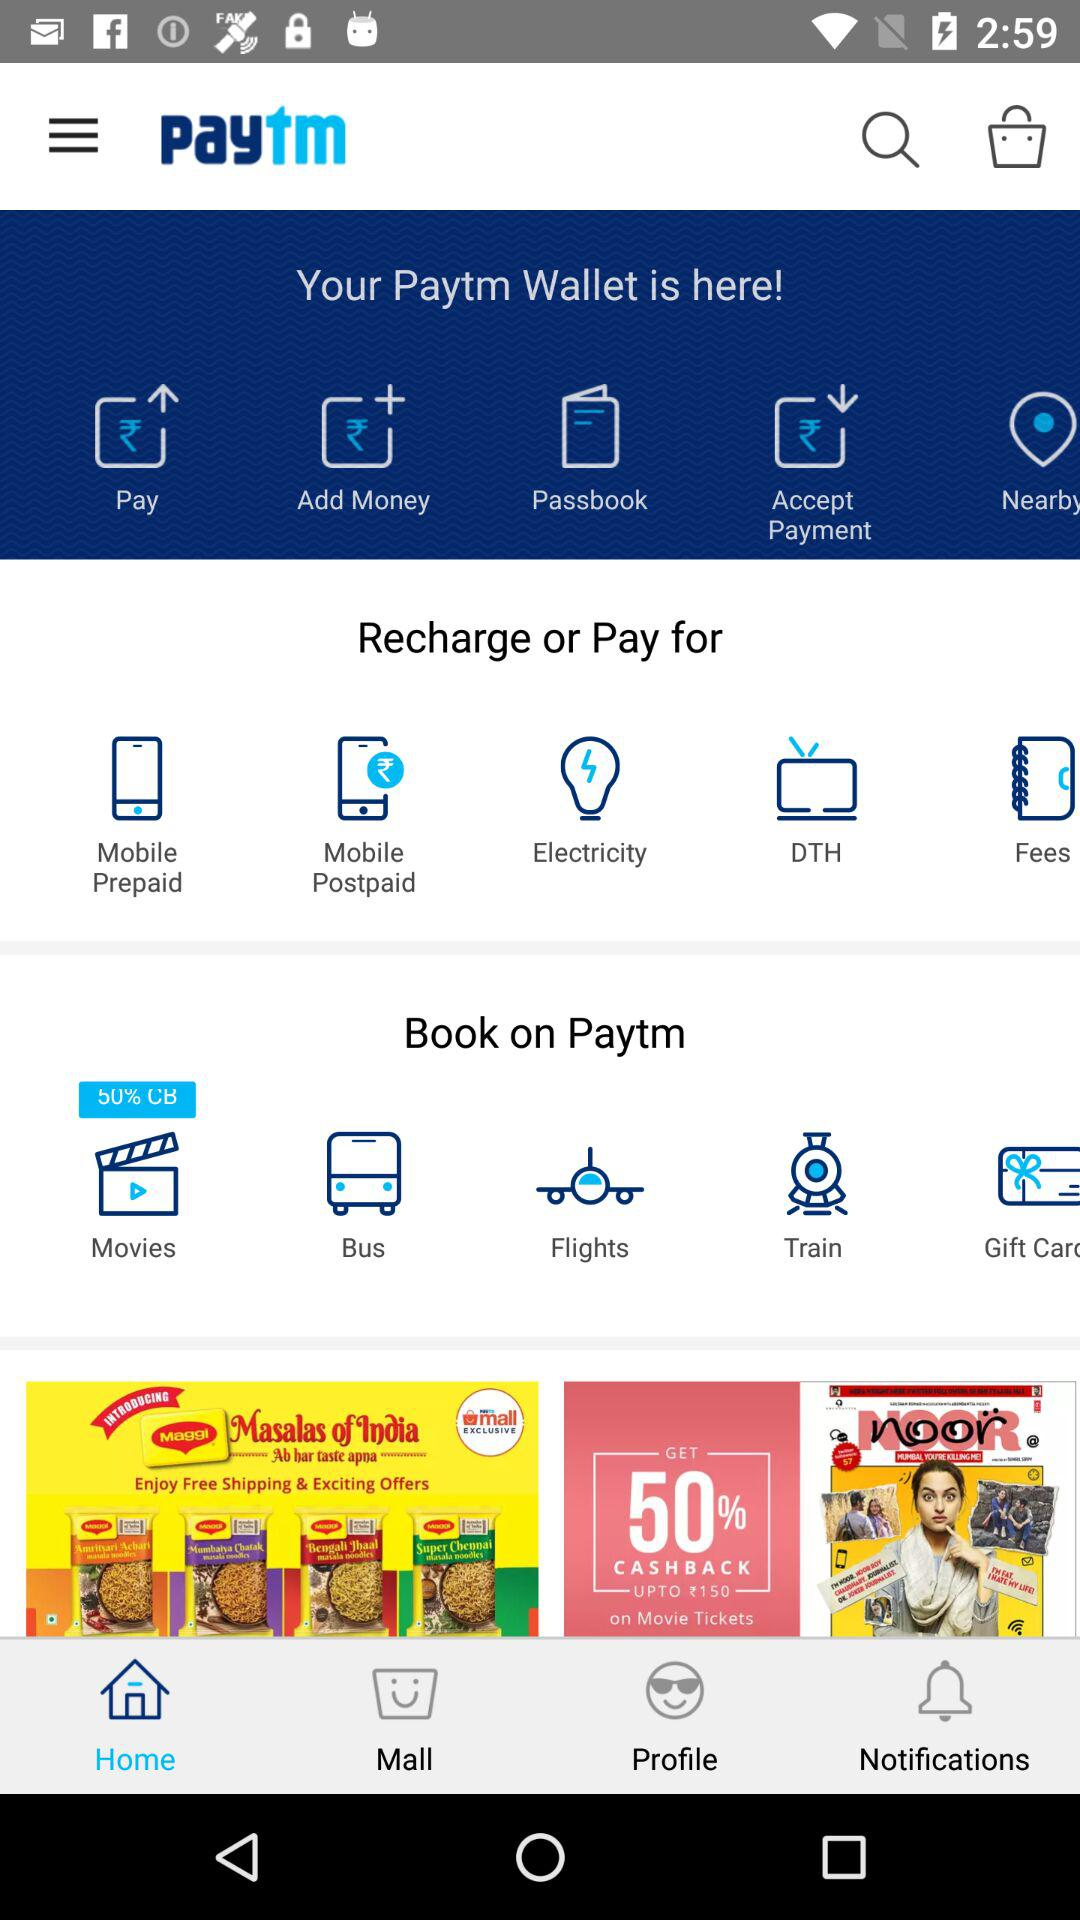How many notifications are there?
When the provided information is insufficient, respond with <no answer>. <no answer> 